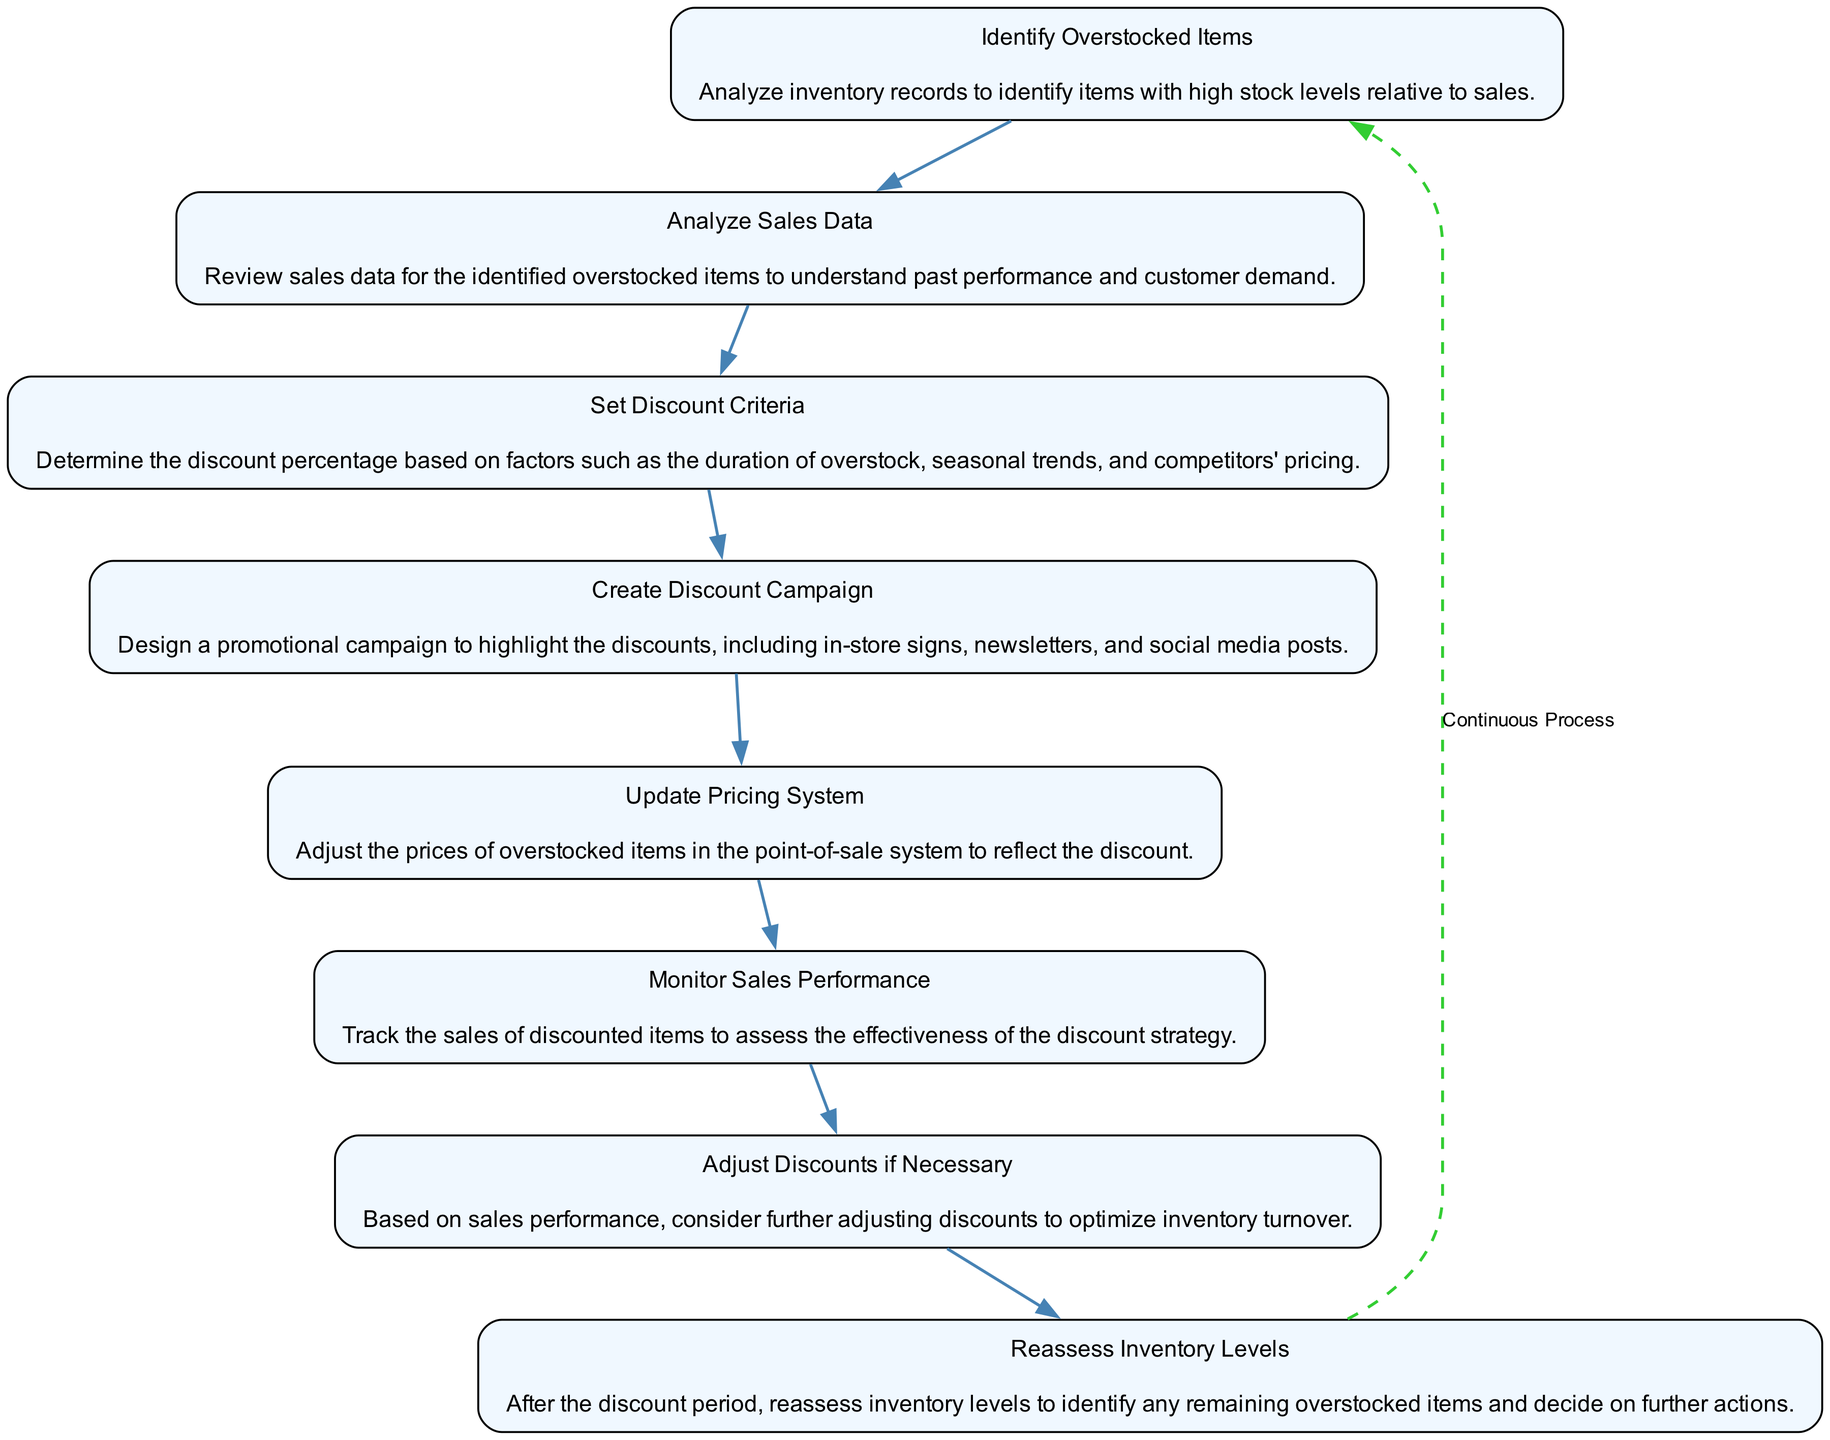What is the first step in the discount strategy? The diagram indicates that the first step is to "Identify Overstocked Items", highlighting the initial focus on analyzing inventory records.
Answer: Identify Overstocked Items How many total steps are there in the discount strategy? By counting the steps in the diagram, we find there are 8 sequential steps from identifying overstocked items to reassessing inventory levels.
Answer: 8 What step follows "Set Discount Criteria"? The flow of the diagram shows that after "Set Discount Criteria," the next step is "Create Discount Campaign," indicating a progression in the strategy.
Answer: Create Discount Campaign What action is taken after monitoring sales performance? According to the flow, once sales performance is monitored, the subsequent action is to "Adjust Discounts if Necessary," which signifies a responsive strategy to sales data.
Answer: Adjust Discounts if Necessary What type of relationship is indicated by the dashed line at the end of the diagram? The dashed line symbolizes a continuous process, representing ongoing cycles of evaluating and adjusting the discount strategy as necessary over time.
Answer: Continuous Process What is analyzed before setting discount criteria? The diagram illustrates that "Analyze Sales Data" is the necessary precursor to "Set Discount Criteria," implying the importance of sales data in informed decision-making.
Answer: Analyze Sales Data How does the discount strategy end? The last step in the diagram is "Reassess Inventory Levels," indicating the final action in the strategy following the discount period.
Answer: Reassess Inventory Levels What is the purpose of the "Create Discount Campaign" step? The focus of this step is to design a promotional campaign to bring attention to the discounts, informing customers effectively through various channels.
Answer: Highlight Discounts What prompts the need to adjust discounts? The need to adjust discounts arises from "Monitor Sales Performance," implying that the effectiveness of the initial discount is evaluated before making changes as necessary.
Answer: Sales Performance 